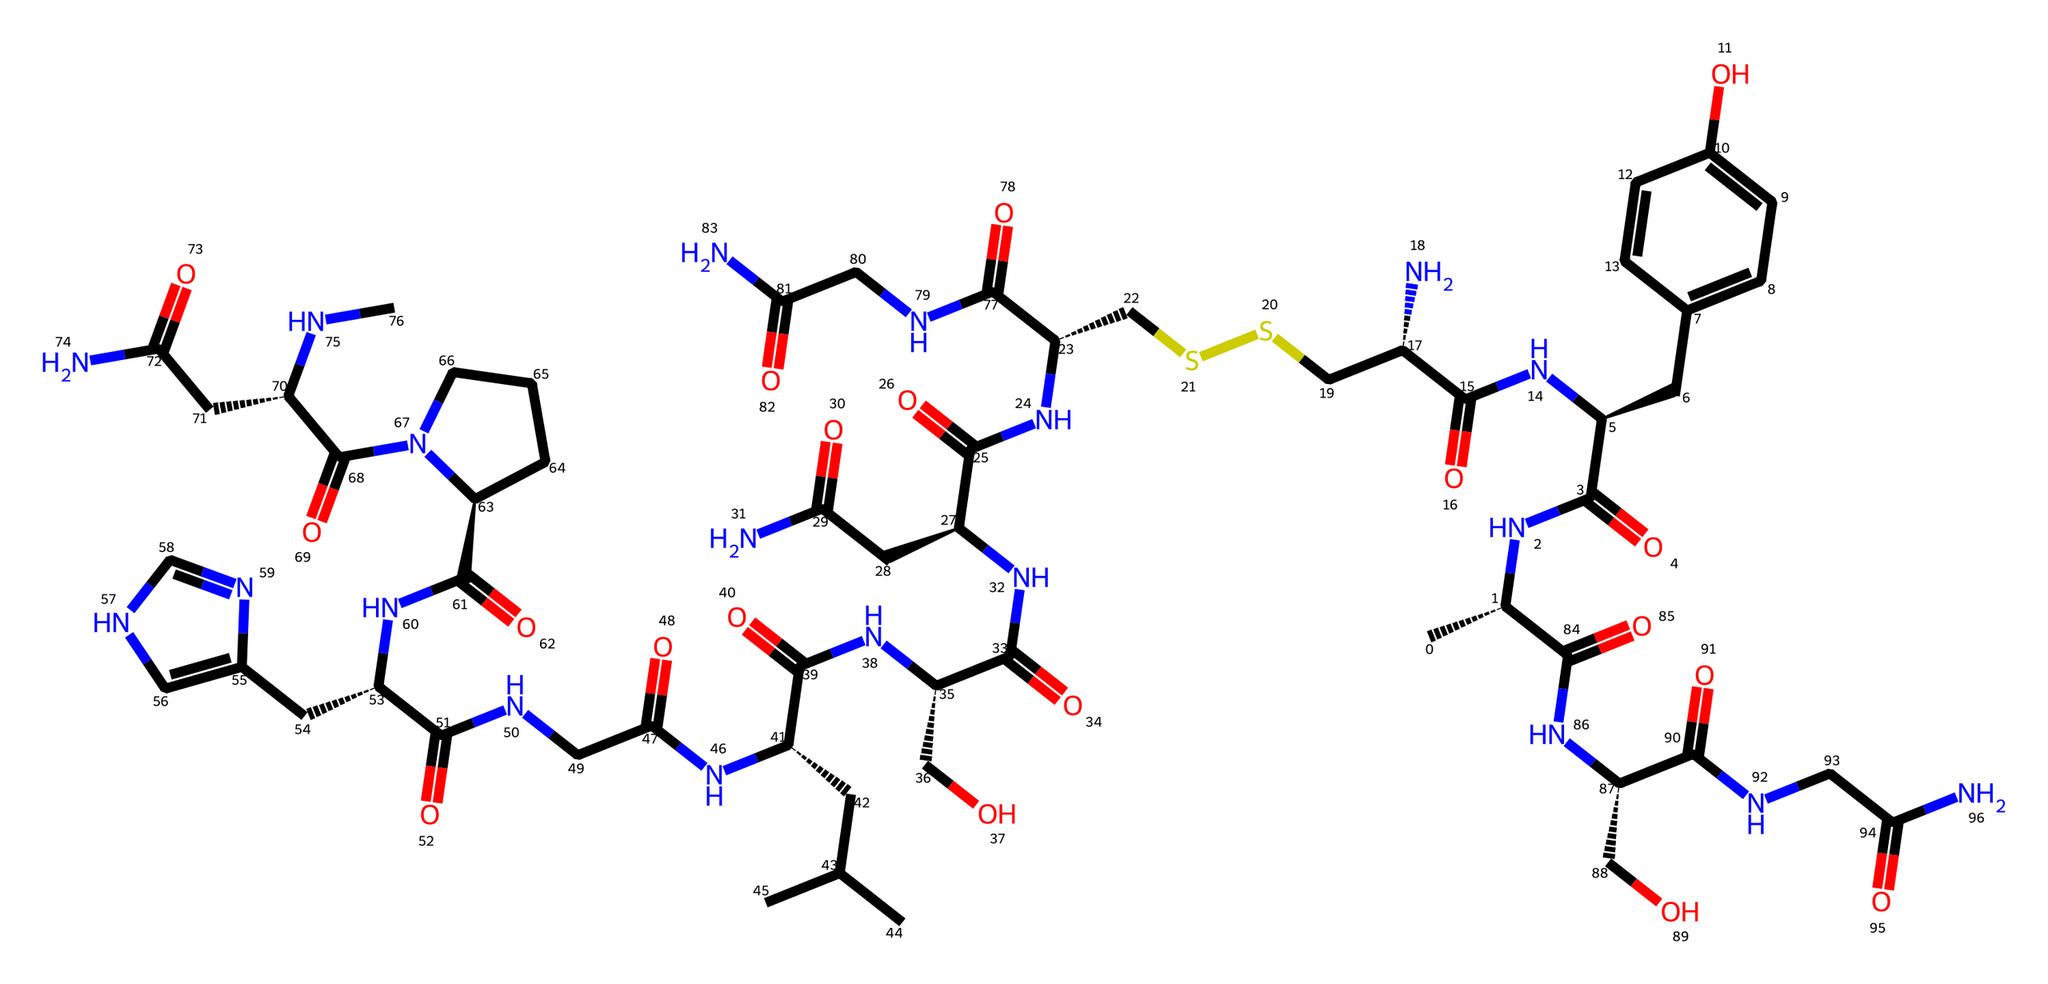What is the molecular formula of oxytocin? To find the molecular formula, we need to count the number of each type of atom present in the SMILES representation. By analyzing the structure, we see that the counts are 27 carbons, 39 hydrogens, 7 nitrogens, and 6 oxygens. Therefore, the molecular formula is C27H39N7O6.
Answer: C27H39N7O6 How many nitrogen atoms are in oxytocin? By examining the SMILES, we can see that there are seven nitrogen (N) atoms present. This count is derived directly from the chemical representation.
Answer: 7 What type of molecule is oxytocin? Oxytocin is a peptide hormone, classified by its structure, which consists of a chain of amino acids. Key features in the SMILES notation include the presence of multiple amide (NC=O) and disulfide (S-S) linkages that characterize peptide hormones.
Answer: peptide hormone Is oxytocin soluble in water? Oxytocin is a hydrophilic molecule due to its polar groups, such as the amide and hydroxyl groups present in its structure. These functional groups allow it to interact favorably with water molecules.
Answer: Yes What is the primary biological function of oxytocin? The primary function of oxytocin is to facilitate social bonding, childbirth, and lactation. This role is supported by its interaction with specific receptors in the human body.
Answer: bonding How many oxygen atoms are present in oxytocin? The analysis of the SMILES shows there are six oxygen (O) atoms present in the structure. This count can be visually confirmed by scanning through the chemical representation for the O symbols.
Answer: 6 What structural feature allows oxytocin to form bonds with its receptors? The presence of specific functional groups, such as the peptide bonds formed by amide linkages (NC=O), enables oxytocin to adopt a specific three-dimensional shape that fits its receptors, facilitating biological interaction.
Answer: peptide bonds 